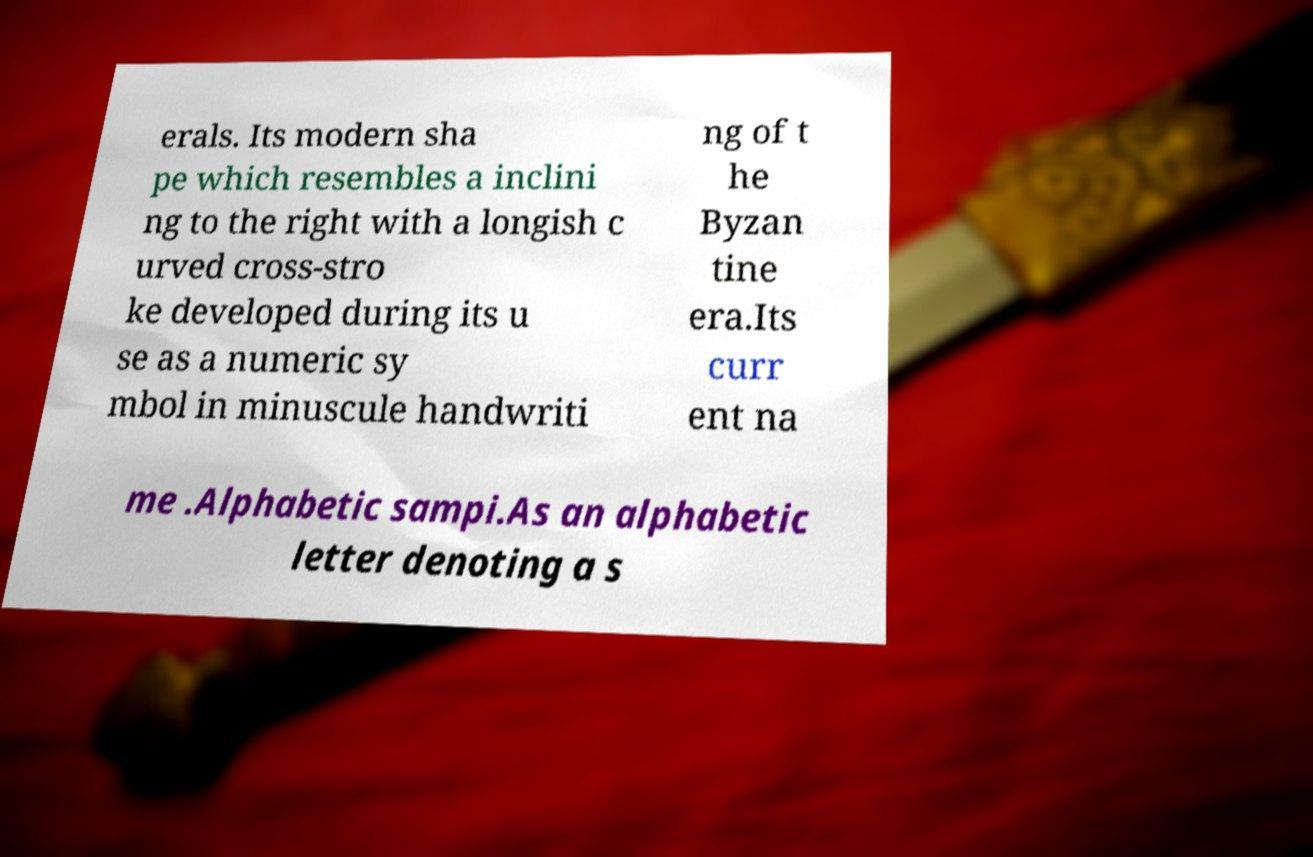What messages or text are displayed in this image? I need them in a readable, typed format. erals. Its modern sha pe which resembles a inclini ng to the right with a longish c urved cross-stro ke developed during its u se as a numeric sy mbol in minuscule handwriti ng of t he Byzan tine era.Its curr ent na me .Alphabetic sampi.As an alphabetic letter denoting a s 